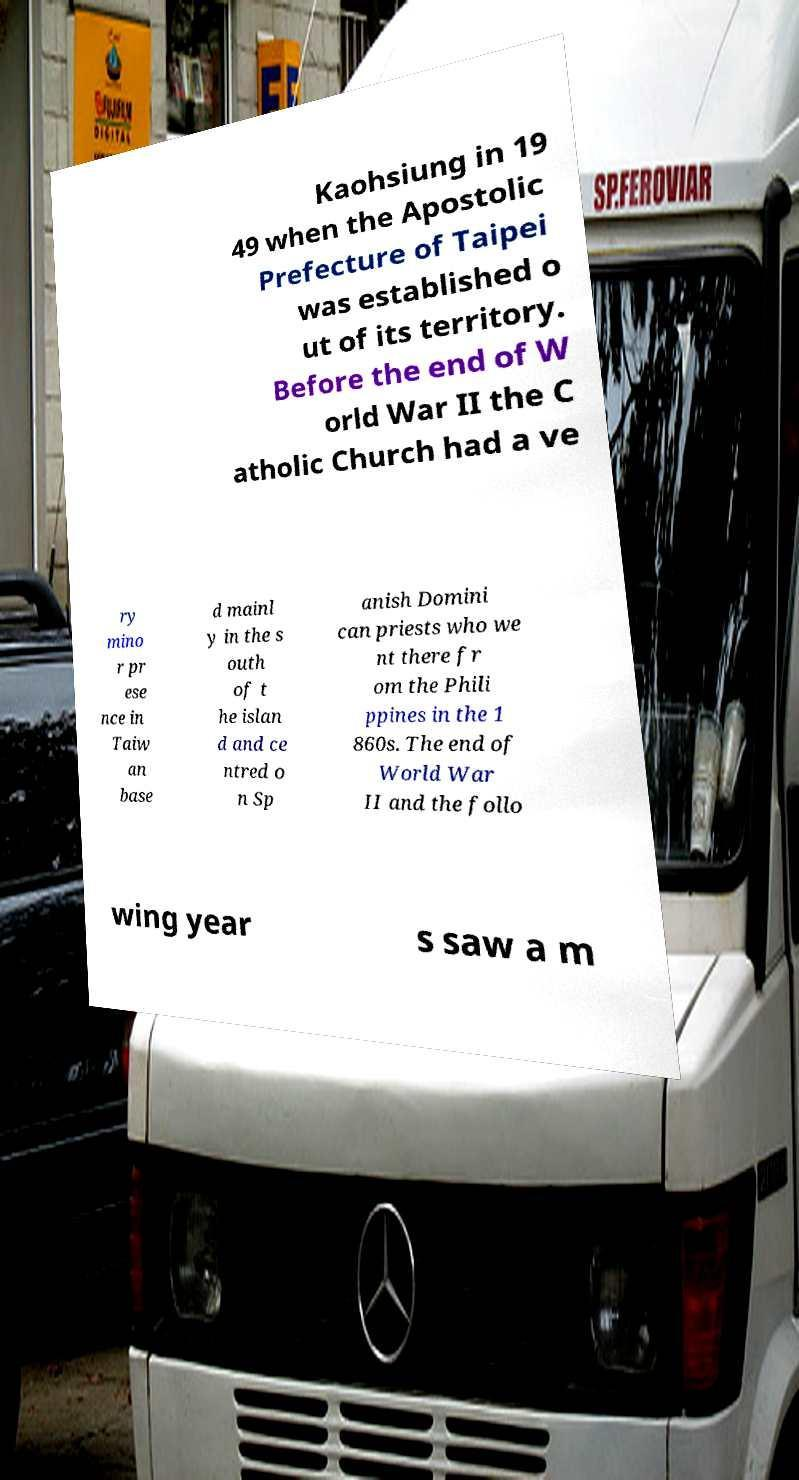I need the written content from this picture converted into text. Can you do that? Kaohsiung in 19 49 when the Apostolic Prefecture of Taipei was established o ut of its territory. Before the end of W orld War II the C atholic Church had a ve ry mino r pr ese nce in Taiw an base d mainl y in the s outh of t he islan d and ce ntred o n Sp anish Domini can priests who we nt there fr om the Phili ppines in the 1 860s. The end of World War II and the follo wing year s saw a m 